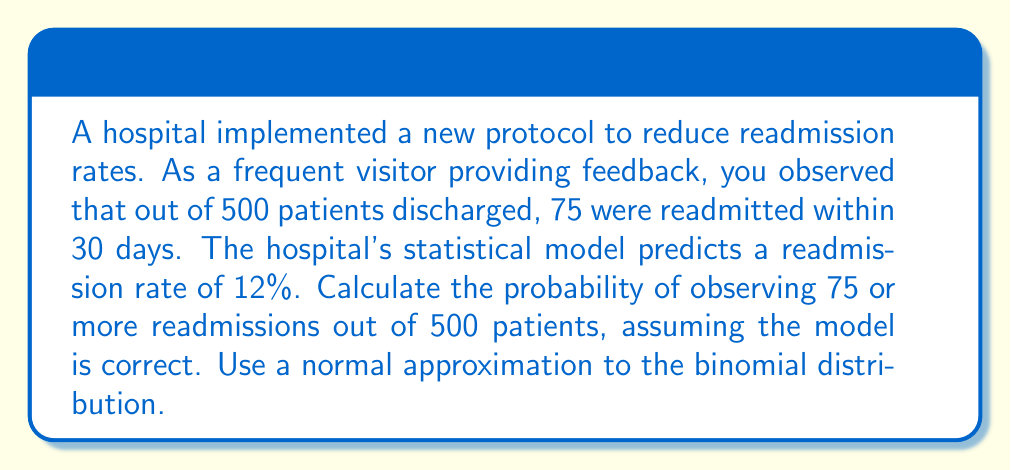Solve this math problem. To solve this problem, we'll use the following steps:

1. Identify the parameters:
   $n = 500$ (number of trials)
   $p = 0.12$ (probability of success)
   $X = 75$ (observed number of readmissions)

2. Calculate the mean and standard deviation of the binomial distribution:
   $\mu = np = 500 \cdot 0.12 = 60$
   $\sigma = \sqrt{np(1-p)} = \sqrt{500 \cdot 0.12 \cdot 0.88} = \sqrt{52.8} \approx 7.27$

3. Calculate the z-score for the observed value:
   $z = \frac{X - \mu}{\sigma} = \frac{75 - 60}{7.27} \approx 2.06$

4. Use the standard normal distribution to find the probability:
   $P(X \geq 75) = P(Z \geq 2.06)$

5. Look up the probability in a standard normal table or use a calculator:
   $P(Z \geq 2.06) \approx 0.0197$

Therefore, the probability of observing 75 or more readmissions out of 500 patients, assuming the model's prediction is correct, is approximately 0.0197 or 1.97%.
Answer: $0.0197$ 